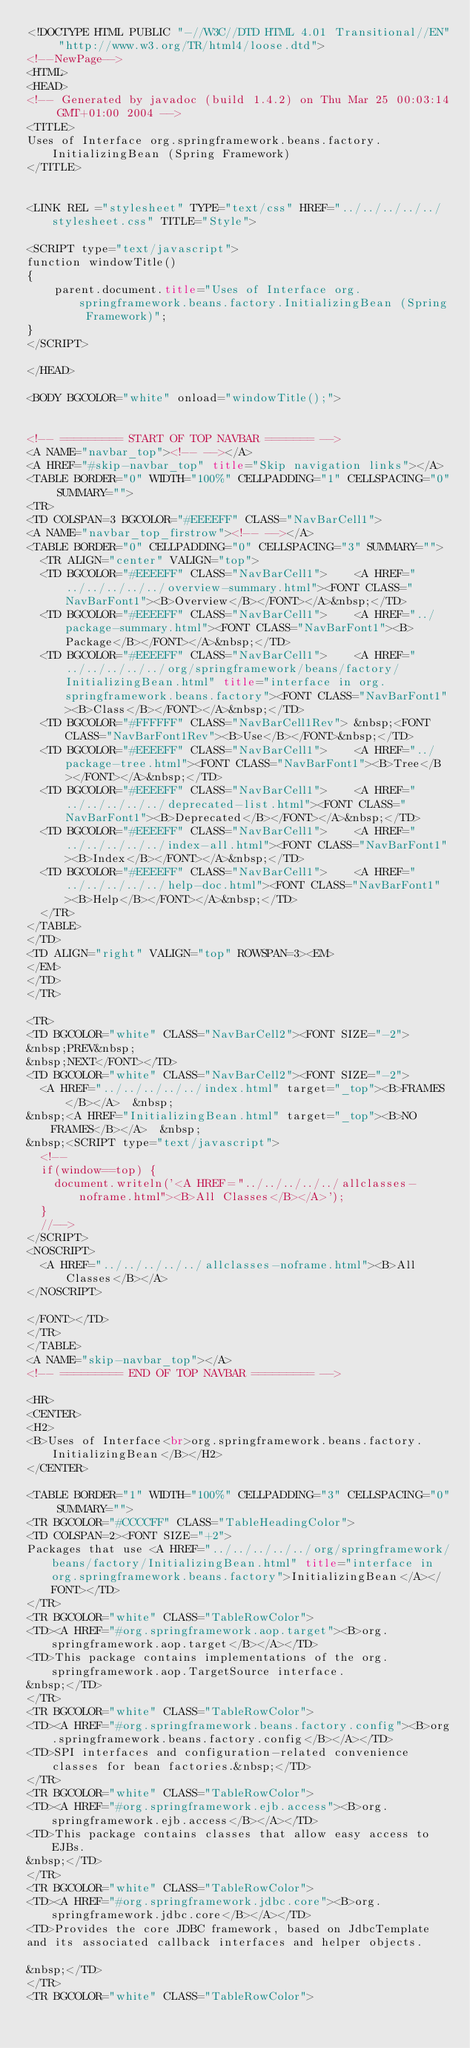<code> <loc_0><loc_0><loc_500><loc_500><_HTML_><!DOCTYPE HTML PUBLIC "-//W3C//DTD HTML 4.01 Transitional//EN" "http://www.w3.org/TR/html4/loose.dtd">
<!--NewPage-->
<HTML>
<HEAD>
<!-- Generated by javadoc (build 1.4.2) on Thu Mar 25 00:03:14 GMT+01:00 2004 -->
<TITLE>
Uses of Interface org.springframework.beans.factory.InitializingBean (Spring Framework)
</TITLE>


<LINK REL ="stylesheet" TYPE="text/css" HREF="../../../../../stylesheet.css" TITLE="Style">

<SCRIPT type="text/javascript">
function windowTitle()
{
    parent.document.title="Uses of Interface org.springframework.beans.factory.InitializingBean (Spring Framework)";
}
</SCRIPT>

</HEAD>

<BODY BGCOLOR="white" onload="windowTitle();">


<!-- ========= START OF TOP NAVBAR ======= -->
<A NAME="navbar_top"><!-- --></A>
<A HREF="#skip-navbar_top" title="Skip navigation links"></A>
<TABLE BORDER="0" WIDTH="100%" CELLPADDING="1" CELLSPACING="0" SUMMARY="">
<TR>
<TD COLSPAN=3 BGCOLOR="#EEEEFF" CLASS="NavBarCell1">
<A NAME="navbar_top_firstrow"><!-- --></A>
<TABLE BORDER="0" CELLPADDING="0" CELLSPACING="3" SUMMARY="">
  <TR ALIGN="center" VALIGN="top">
  <TD BGCOLOR="#EEEEFF" CLASS="NavBarCell1">    <A HREF="../../../../../overview-summary.html"><FONT CLASS="NavBarFont1"><B>Overview</B></FONT></A>&nbsp;</TD>
  <TD BGCOLOR="#EEEEFF" CLASS="NavBarCell1">    <A HREF="../package-summary.html"><FONT CLASS="NavBarFont1"><B>Package</B></FONT></A>&nbsp;</TD>
  <TD BGCOLOR="#EEEEFF" CLASS="NavBarCell1">    <A HREF="../../../../../org/springframework/beans/factory/InitializingBean.html" title="interface in org.springframework.beans.factory"><FONT CLASS="NavBarFont1"><B>Class</B></FONT></A>&nbsp;</TD>
  <TD BGCOLOR="#FFFFFF" CLASS="NavBarCell1Rev"> &nbsp;<FONT CLASS="NavBarFont1Rev"><B>Use</B></FONT>&nbsp;</TD>
  <TD BGCOLOR="#EEEEFF" CLASS="NavBarCell1">    <A HREF="../package-tree.html"><FONT CLASS="NavBarFont1"><B>Tree</B></FONT></A>&nbsp;</TD>
  <TD BGCOLOR="#EEEEFF" CLASS="NavBarCell1">    <A HREF="../../../../../deprecated-list.html"><FONT CLASS="NavBarFont1"><B>Deprecated</B></FONT></A>&nbsp;</TD>
  <TD BGCOLOR="#EEEEFF" CLASS="NavBarCell1">    <A HREF="../../../../../index-all.html"><FONT CLASS="NavBarFont1"><B>Index</B></FONT></A>&nbsp;</TD>
  <TD BGCOLOR="#EEEEFF" CLASS="NavBarCell1">    <A HREF="../../../../../help-doc.html"><FONT CLASS="NavBarFont1"><B>Help</B></FONT></A>&nbsp;</TD>
  </TR>
</TABLE>
</TD>
<TD ALIGN="right" VALIGN="top" ROWSPAN=3><EM>
</EM>
</TD>
</TR>

<TR>
<TD BGCOLOR="white" CLASS="NavBarCell2"><FONT SIZE="-2">
&nbsp;PREV&nbsp;
&nbsp;NEXT</FONT></TD>
<TD BGCOLOR="white" CLASS="NavBarCell2"><FONT SIZE="-2">
  <A HREF="../../../../../index.html" target="_top"><B>FRAMES</B></A>  &nbsp;
&nbsp;<A HREF="InitializingBean.html" target="_top"><B>NO FRAMES</B></A>  &nbsp;
&nbsp;<SCRIPT type="text/javascript">
  <!--
  if(window==top) {
    document.writeln('<A HREF="../../../../../allclasses-noframe.html"><B>All Classes</B></A>');
  }
  //-->
</SCRIPT>
<NOSCRIPT>
  <A HREF="../../../../../allclasses-noframe.html"><B>All Classes</B></A>
</NOSCRIPT>

</FONT></TD>
</TR>
</TABLE>
<A NAME="skip-navbar_top"></A>
<!-- ========= END OF TOP NAVBAR ========= -->

<HR>
<CENTER>
<H2>
<B>Uses of Interface<br>org.springframework.beans.factory.InitializingBean</B></H2>
</CENTER>

<TABLE BORDER="1" WIDTH="100%" CELLPADDING="3" CELLSPACING="0" SUMMARY="">
<TR BGCOLOR="#CCCCFF" CLASS="TableHeadingColor">
<TD COLSPAN=2><FONT SIZE="+2">
Packages that use <A HREF="../../../../../org/springframework/beans/factory/InitializingBean.html" title="interface in org.springframework.beans.factory">InitializingBean</A></FONT></TD>
</TR>
<TR BGCOLOR="white" CLASS="TableRowColor">
<TD><A HREF="#org.springframework.aop.target"><B>org.springframework.aop.target</B></A></TD>
<TD>This package contains implementations of the org.springframework.aop.TargetSource interface.
&nbsp;</TD>
</TR>
<TR BGCOLOR="white" CLASS="TableRowColor">
<TD><A HREF="#org.springframework.beans.factory.config"><B>org.springframework.beans.factory.config</B></A></TD>
<TD>SPI interfaces and configuration-related convenience classes for bean factories.&nbsp;</TD>
</TR>
<TR BGCOLOR="white" CLASS="TableRowColor">
<TD><A HREF="#org.springframework.ejb.access"><B>org.springframework.ejb.access</B></A></TD>
<TD>This package contains classes that allow easy access to EJBs.
&nbsp;</TD>
</TR>
<TR BGCOLOR="white" CLASS="TableRowColor">
<TD><A HREF="#org.springframework.jdbc.core"><B>org.springframework.jdbc.core</B></A></TD>
<TD>Provides the core JDBC framework, based on JdbcTemplate
and its associated callback interfaces and helper objects.

&nbsp;</TD>
</TR>
<TR BGCOLOR="white" CLASS="TableRowColor"></code> 